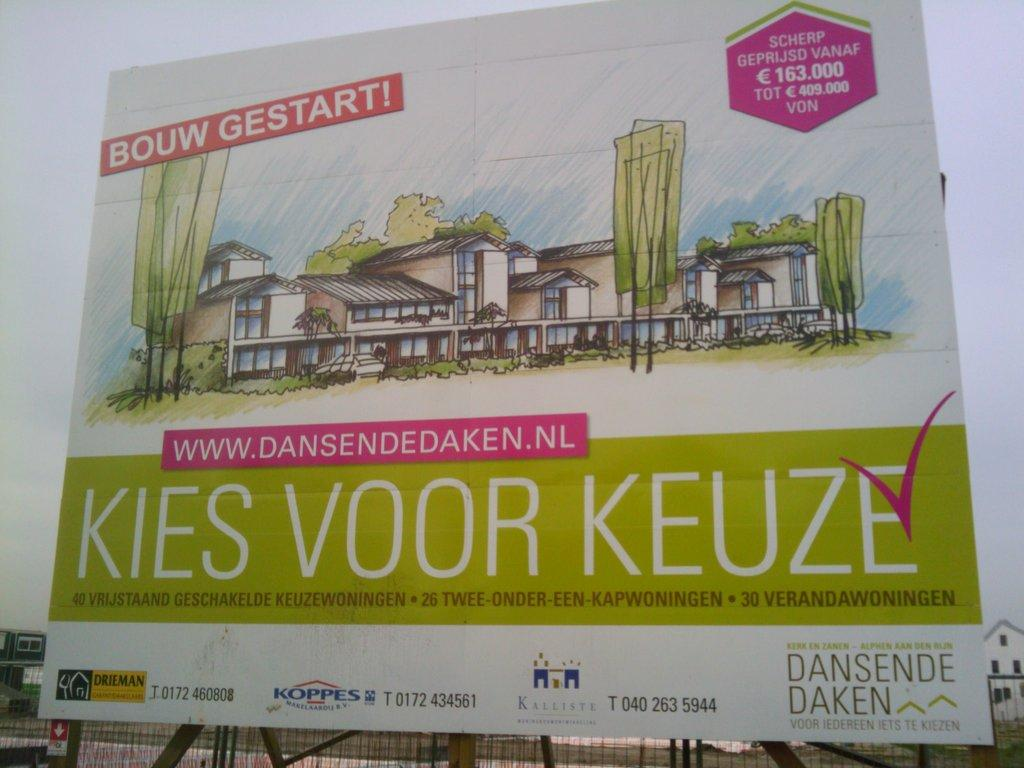Provide a one-sentence caption for the provided image. An architectural rendering in a sign to advertise a development in the Netherlands. 